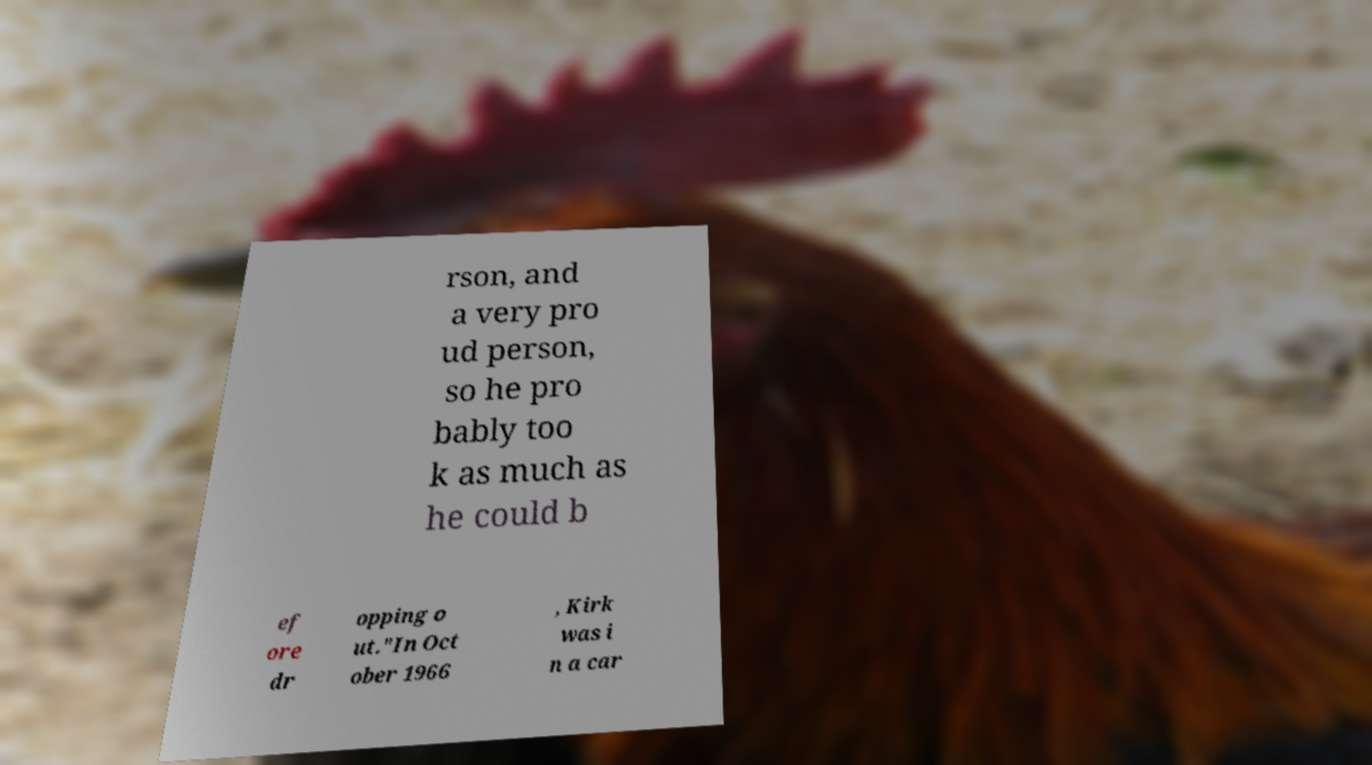Can you accurately transcribe the text from the provided image for me? rson, and a very pro ud person, so he pro bably too k as much as he could b ef ore dr opping o ut."In Oct ober 1966 , Kirk was i n a car 